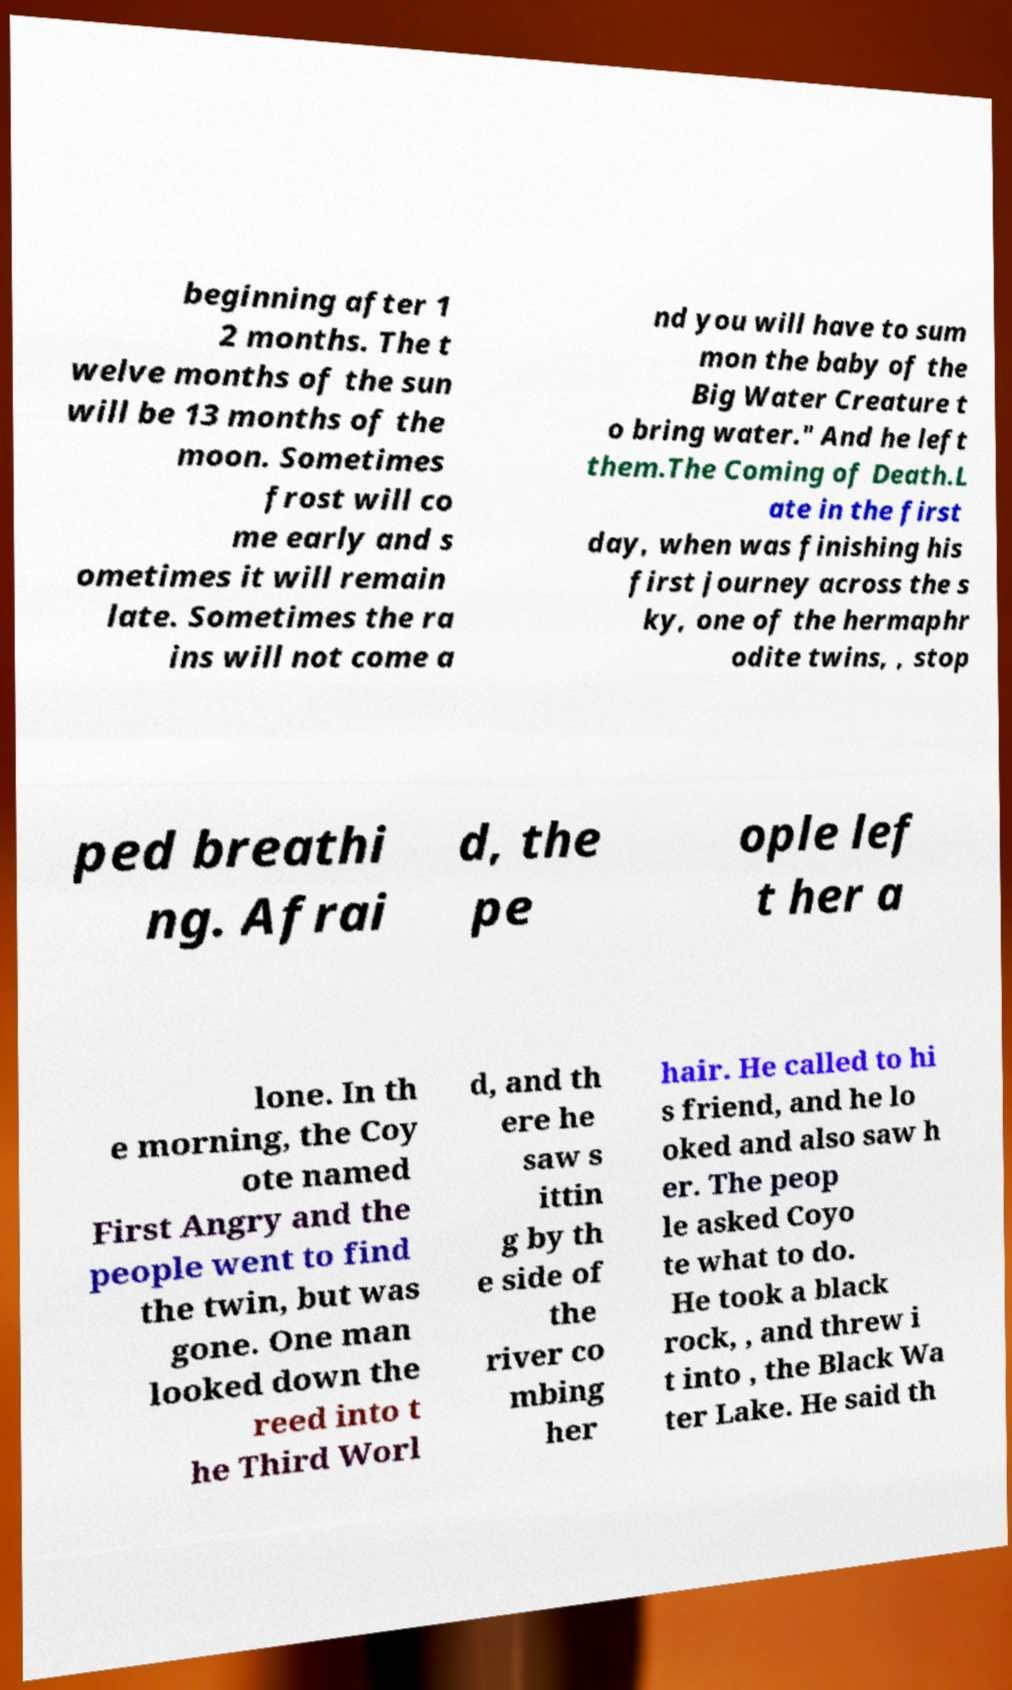Could you assist in decoding the text presented in this image and type it out clearly? beginning after 1 2 months. The t welve months of the sun will be 13 months of the moon. Sometimes frost will co me early and s ometimes it will remain late. Sometimes the ra ins will not come a nd you will have to sum mon the baby of the Big Water Creature t o bring water." And he left them.The Coming of Death.L ate in the first day, when was finishing his first journey across the s ky, one of the hermaphr odite twins, , stop ped breathi ng. Afrai d, the pe ople lef t her a lone. In th e morning, the Coy ote named First Angry and the people went to find the twin, but was gone. One man looked down the reed into t he Third Worl d, and th ere he saw s ittin g by th e side of the river co mbing her hair. He called to hi s friend, and he lo oked and also saw h er. The peop le asked Coyo te what to do. He took a black rock, , and threw i t into , the Black Wa ter Lake. He said th 